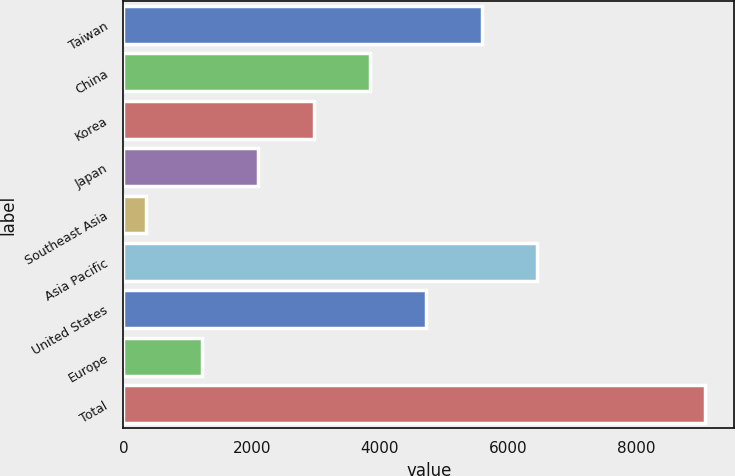<chart> <loc_0><loc_0><loc_500><loc_500><bar_chart><fcel>Taiwan<fcel>China<fcel>Korea<fcel>Japan<fcel>Southeast Asia<fcel>Asia Pacific<fcel>United States<fcel>Europe<fcel>Total<nl><fcel>5585.6<fcel>3842.4<fcel>2970.8<fcel>2099.2<fcel>356<fcel>6457.2<fcel>4714<fcel>1227.6<fcel>9072<nl></chart> 